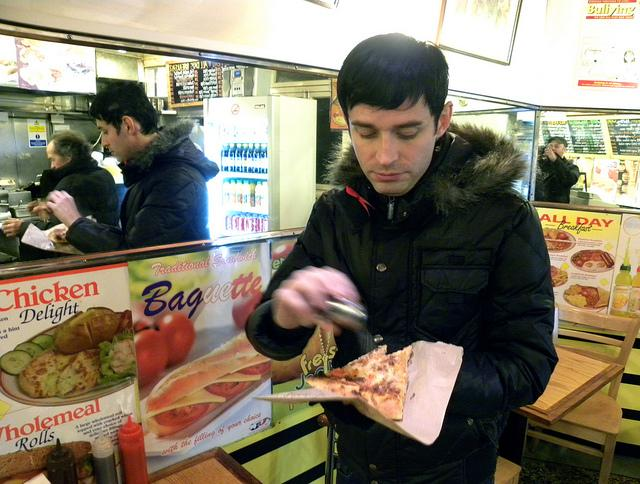What is he doing with the pizza?

Choices:
A) stealing it
B) adding flavor
C) eating it
D) returning it adding flavor 